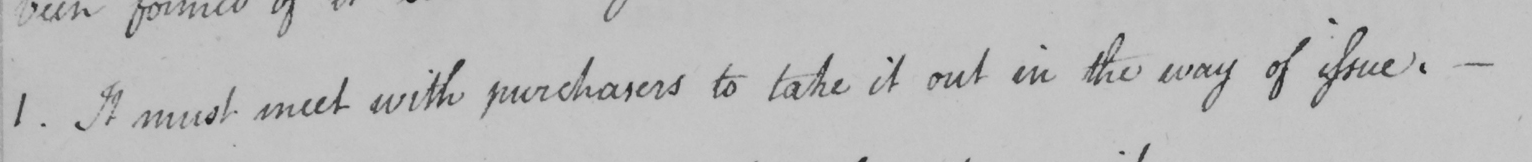What does this handwritten line say? 1 . It must meet with purchasers to take it out in the way of issue .  _ 